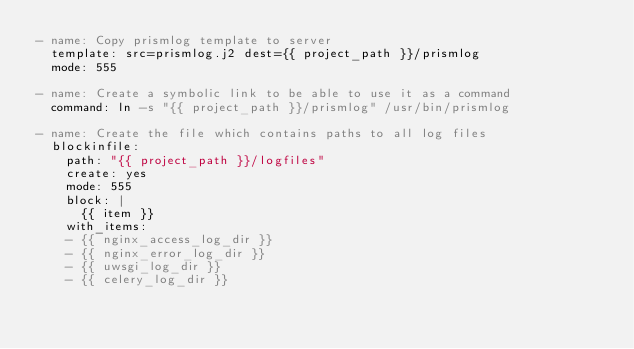Convert code to text. <code><loc_0><loc_0><loc_500><loc_500><_YAML_>- name: Copy prismlog template to server
  template: src=prismlog.j2 dest={{ project_path }}/prismlog
  mode: 555

- name: Create a symbolic link to be able to use it as a command
  command: ln -s "{{ project_path }}/prismlog" /usr/bin/prismlog

- name: Create the file which contains paths to all log files
  blockinfile:
    path: "{{ project_path }}/logfiles"
    create: yes
    mode: 555
    block: |
      {{ item }}
    with_items:
    - {{ nginx_access_log_dir }}
    - {{ nginx_error_log_dir }}
    - {{ uwsgi_log_dir }}
    - {{ celery_log_dir }}

</code> 